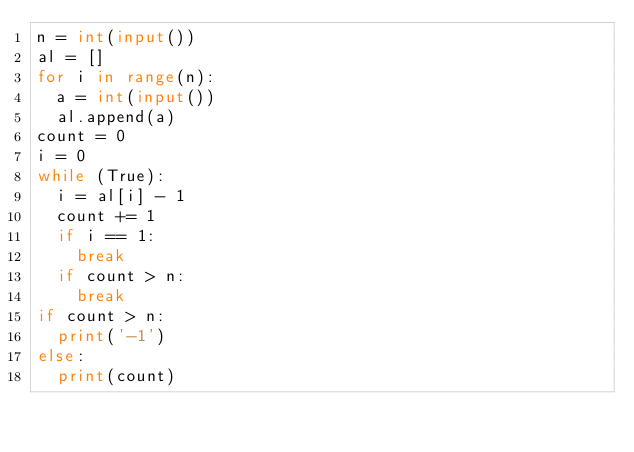Convert code to text. <code><loc_0><loc_0><loc_500><loc_500><_Python_>n = int(input())
al = []
for i in range(n):
  a = int(input())
  al.append(a)
count = 0
i = 0
while (True):
  i = al[i] - 1
  count += 1
  if i == 1:
    break
  if count > n:
    break
if count > n:
  print('-1')
else:
  print(count)
</code> 